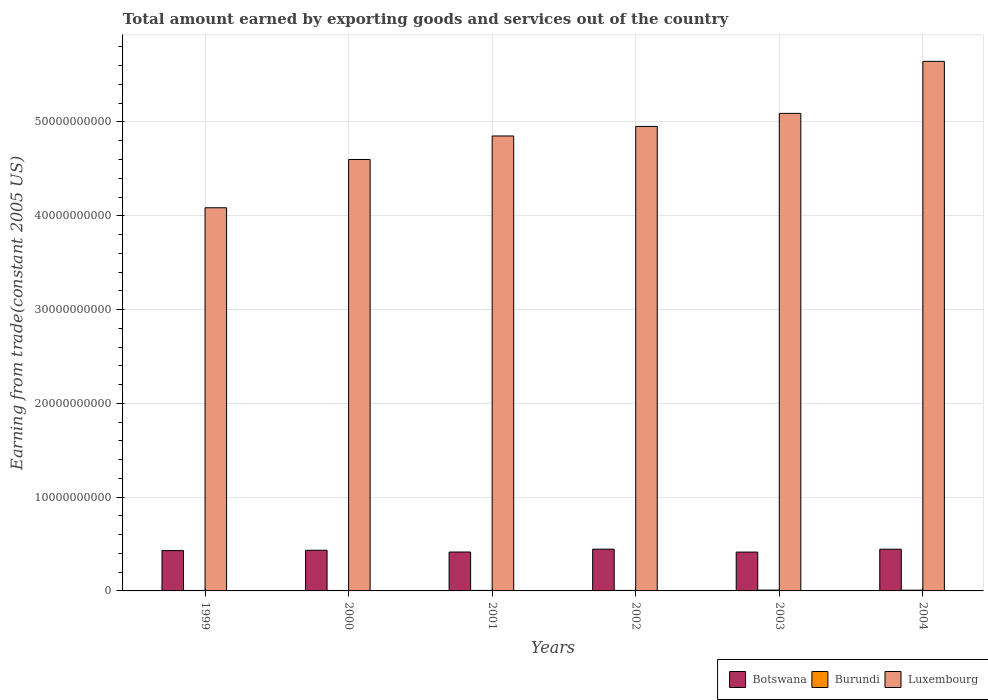Are the number of bars per tick equal to the number of legend labels?
Provide a short and direct response. Yes. Are the number of bars on each tick of the X-axis equal?
Your answer should be compact. Yes. How many bars are there on the 1st tick from the left?
Offer a very short reply. 3. What is the label of the 2nd group of bars from the left?
Provide a short and direct response. 2000. In how many cases, is the number of bars for a given year not equal to the number of legend labels?
Offer a terse response. 0. What is the total amount earned by exporting goods and services in Luxembourg in 2001?
Provide a succinct answer. 4.85e+1. Across all years, what is the maximum total amount earned by exporting goods and services in Burundi?
Offer a very short reply. 8.68e+07. Across all years, what is the minimum total amount earned by exporting goods and services in Botswana?
Your answer should be very brief. 4.14e+09. What is the total total amount earned by exporting goods and services in Burundi in the graph?
Your response must be concise. 3.69e+08. What is the difference between the total amount earned by exporting goods and services in Burundi in 2002 and that in 2004?
Make the answer very short. -2.42e+07. What is the difference between the total amount earned by exporting goods and services in Botswana in 2003 and the total amount earned by exporting goods and services in Luxembourg in 1999?
Provide a short and direct response. -3.67e+1. What is the average total amount earned by exporting goods and services in Burundi per year?
Make the answer very short. 6.16e+07. In the year 1999, what is the difference between the total amount earned by exporting goods and services in Botswana and total amount earned by exporting goods and services in Burundi?
Offer a terse response. 4.25e+09. What is the ratio of the total amount earned by exporting goods and services in Botswana in 2000 to that in 2001?
Your response must be concise. 1.05. Is the total amount earned by exporting goods and services in Burundi in 1999 less than that in 2003?
Provide a short and direct response. Yes. What is the difference between the highest and the second highest total amount earned by exporting goods and services in Luxembourg?
Provide a succinct answer. 5.55e+09. What is the difference between the highest and the lowest total amount earned by exporting goods and services in Botswana?
Your answer should be compact. 3.12e+08. Is the sum of the total amount earned by exporting goods and services in Luxembourg in 2000 and 2001 greater than the maximum total amount earned by exporting goods and services in Burundi across all years?
Offer a very short reply. Yes. What does the 3rd bar from the left in 2004 represents?
Keep it short and to the point. Luxembourg. What does the 2nd bar from the right in 2003 represents?
Make the answer very short. Burundi. Are all the bars in the graph horizontal?
Keep it short and to the point. No. How many years are there in the graph?
Offer a very short reply. 6. What is the difference between two consecutive major ticks on the Y-axis?
Offer a terse response. 1.00e+1. Does the graph contain any zero values?
Make the answer very short. No. Does the graph contain grids?
Your answer should be compact. Yes. How are the legend labels stacked?
Provide a succinct answer. Horizontal. What is the title of the graph?
Offer a very short reply. Total amount earned by exporting goods and services out of the country. Does "Luxembourg" appear as one of the legend labels in the graph?
Offer a terse response. Yes. What is the label or title of the Y-axis?
Your answer should be compact. Earning from trade(constant 2005 US). What is the Earning from trade(constant 2005 US) of Botswana in 1999?
Provide a succinct answer. 4.30e+09. What is the Earning from trade(constant 2005 US) of Burundi in 1999?
Make the answer very short. 4.87e+07. What is the Earning from trade(constant 2005 US) of Luxembourg in 1999?
Your answer should be very brief. 4.09e+1. What is the Earning from trade(constant 2005 US) in Botswana in 2000?
Give a very brief answer. 4.34e+09. What is the Earning from trade(constant 2005 US) of Burundi in 2000?
Provide a short and direct response. 4.50e+07. What is the Earning from trade(constant 2005 US) in Luxembourg in 2000?
Provide a succinct answer. 4.60e+1. What is the Earning from trade(constant 2005 US) in Botswana in 2001?
Offer a terse response. 4.15e+09. What is the Earning from trade(constant 2005 US) of Burundi in 2001?
Your answer should be compact. 5.65e+07. What is the Earning from trade(constant 2005 US) in Luxembourg in 2001?
Provide a succinct answer. 4.85e+1. What is the Earning from trade(constant 2005 US) in Botswana in 2002?
Give a very brief answer. 4.45e+09. What is the Earning from trade(constant 2005 US) of Burundi in 2002?
Your answer should be compact. 5.41e+07. What is the Earning from trade(constant 2005 US) in Luxembourg in 2002?
Give a very brief answer. 4.95e+1. What is the Earning from trade(constant 2005 US) of Botswana in 2003?
Keep it short and to the point. 4.14e+09. What is the Earning from trade(constant 2005 US) in Burundi in 2003?
Make the answer very short. 8.68e+07. What is the Earning from trade(constant 2005 US) of Luxembourg in 2003?
Provide a succinct answer. 5.09e+1. What is the Earning from trade(constant 2005 US) in Botswana in 2004?
Keep it short and to the point. 4.45e+09. What is the Earning from trade(constant 2005 US) in Burundi in 2004?
Provide a succinct answer. 7.84e+07. What is the Earning from trade(constant 2005 US) in Luxembourg in 2004?
Your answer should be very brief. 5.65e+1. Across all years, what is the maximum Earning from trade(constant 2005 US) of Botswana?
Your answer should be very brief. 4.45e+09. Across all years, what is the maximum Earning from trade(constant 2005 US) of Burundi?
Ensure brevity in your answer.  8.68e+07. Across all years, what is the maximum Earning from trade(constant 2005 US) of Luxembourg?
Ensure brevity in your answer.  5.65e+1. Across all years, what is the minimum Earning from trade(constant 2005 US) of Botswana?
Provide a succinct answer. 4.14e+09. Across all years, what is the minimum Earning from trade(constant 2005 US) of Burundi?
Provide a short and direct response. 4.50e+07. Across all years, what is the minimum Earning from trade(constant 2005 US) of Luxembourg?
Ensure brevity in your answer.  4.09e+1. What is the total Earning from trade(constant 2005 US) in Botswana in the graph?
Ensure brevity in your answer.  2.58e+1. What is the total Earning from trade(constant 2005 US) in Burundi in the graph?
Offer a terse response. 3.69e+08. What is the total Earning from trade(constant 2005 US) in Luxembourg in the graph?
Your answer should be compact. 2.92e+11. What is the difference between the Earning from trade(constant 2005 US) of Botswana in 1999 and that in 2000?
Give a very brief answer. -3.46e+07. What is the difference between the Earning from trade(constant 2005 US) in Burundi in 1999 and that in 2000?
Offer a terse response. 3.70e+06. What is the difference between the Earning from trade(constant 2005 US) in Luxembourg in 1999 and that in 2000?
Ensure brevity in your answer.  -5.15e+09. What is the difference between the Earning from trade(constant 2005 US) in Botswana in 1999 and that in 2001?
Keep it short and to the point. 1.54e+08. What is the difference between the Earning from trade(constant 2005 US) in Burundi in 1999 and that in 2001?
Make the answer very short. -7.73e+06. What is the difference between the Earning from trade(constant 2005 US) in Luxembourg in 1999 and that in 2001?
Keep it short and to the point. -7.65e+09. What is the difference between the Earning from trade(constant 2005 US) of Botswana in 1999 and that in 2002?
Ensure brevity in your answer.  -1.51e+08. What is the difference between the Earning from trade(constant 2005 US) of Burundi in 1999 and that in 2002?
Offer a very short reply. -5.39e+06. What is the difference between the Earning from trade(constant 2005 US) in Luxembourg in 1999 and that in 2002?
Provide a succinct answer. -8.67e+09. What is the difference between the Earning from trade(constant 2005 US) of Botswana in 1999 and that in 2003?
Your answer should be very brief. 1.61e+08. What is the difference between the Earning from trade(constant 2005 US) of Burundi in 1999 and that in 2003?
Your answer should be compact. -3.80e+07. What is the difference between the Earning from trade(constant 2005 US) in Luxembourg in 1999 and that in 2003?
Ensure brevity in your answer.  -1.01e+1. What is the difference between the Earning from trade(constant 2005 US) in Botswana in 1999 and that in 2004?
Provide a short and direct response. -1.45e+08. What is the difference between the Earning from trade(constant 2005 US) in Burundi in 1999 and that in 2004?
Your answer should be very brief. -2.96e+07. What is the difference between the Earning from trade(constant 2005 US) of Luxembourg in 1999 and that in 2004?
Offer a terse response. -1.56e+1. What is the difference between the Earning from trade(constant 2005 US) of Botswana in 2000 and that in 2001?
Offer a very short reply. 1.88e+08. What is the difference between the Earning from trade(constant 2005 US) of Burundi in 2000 and that in 2001?
Provide a succinct answer. -1.14e+07. What is the difference between the Earning from trade(constant 2005 US) of Luxembourg in 2000 and that in 2001?
Provide a short and direct response. -2.51e+09. What is the difference between the Earning from trade(constant 2005 US) of Botswana in 2000 and that in 2002?
Your answer should be compact. -1.16e+08. What is the difference between the Earning from trade(constant 2005 US) in Burundi in 2000 and that in 2002?
Give a very brief answer. -9.10e+06. What is the difference between the Earning from trade(constant 2005 US) in Luxembourg in 2000 and that in 2002?
Make the answer very short. -3.52e+09. What is the difference between the Earning from trade(constant 2005 US) in Botswana in 2000 and that in 2003?
Make the answer very short. 1.95e+08. What is the difference between the Earning from trade(constant 2005 US) in Burundi in 2000 and that in 2003?
Offer a terse response. -4.18e+07. What is the difference between the Earning from trade(constant 2005 US) in Luxembourg in 2000 and that in 2003?
Make the answer very short. -4.92e+09. What is the difference between the Earning from trade(constant 2005 US) in Botswana in 2000 and that in 2004?
Your answer should be very brief. -1.11e+08. What is the difference between the Earning from trade(constant 2005 US) in Burundi in 2000 and that in 2004?
Offer a terse response. -3.33e+07. What is the difference between the Earning from trade(constant 2005 US) in Luxembourg in 2000 and that in 2004?
Provide a short and direct response. -1.05e+1. What is the difference between the Earning from trade(constant 2005 US) in Botswana in 2001 and that in 2002?
Make the answer very short. -3.05e+08. What is the difference between the Earning from trade(constant 2005 US) in Burundi in 2001 and that in 2002?
Provide a short and direct response. 2.34e+06. What is the difference between the Earning from trade(constant 2005 US) in Luxembourg in 2001 and that in 2002?
Provide a short and direct response. -1.02e+09. What is the difference between the Earning from trade(constant 2005 US) of Botswana in 2001 and that in 2003?
Ensure brevity in your answer.  6.96e+06. What is the difference between the Earning from trade(constant 2005 US) of Burundi in 2001 and that in 2003?
Offer a very short reply. -3.03e+07. What is the difference between the Earning from trade(constant 2005 US) in Luxembourg in 2001 and that in 2003?
Make the answer very short. -2.41e+09. What is the difference between the Earning from trade(constant 2005 US) of Botswana in 2001 and that in 2004?
Keep it short and to the point. -2.99e+08. What is the difference between the Earning from trade(constant 2005 US) of Burundi in 2001 and that in 2004?
Your answer should be very brief. -2.19e+07. What is the difference between the Earning from trade(constant 2005 US) in Luxembourg in 2001 and that in 2004?
Keep it short and to the point. -7.96e+09. What is the difference between the Earning from trade(constant 2005 US) in Botswana in 2002 and that in 2003?
Your response must be concise. 3.12e+08. What is the difference between the Earning from trade(constant 2005 US) of Burundi in 2002 and that in 2003?
Your answer should be very brief. -3.27e+07. What is the difference between the Earning from trade(constant 2005 US) of Luxembourg in 2002 and that in 2003?
Your answer should be compact. -1.39e+09. What is the difference between the Earning from trade(constant 2005 US) of Botswana in 2002 and that in 2004?
Make the answer very short. 5.68e+06. What is the difference between the Earning from trade(constant 2005 US) of Burundi in 2002 and that in 2004?
Offer a terse response. -2.42e+07. What is the difference between the Earning from trade(constant 2005 US) in Luxembourg in 2002 and that in 2004?
Make the answer very short. -6.94e+09. What is the difference between the Earning from trade(constant 2005 US) in Botswana in 2003 and that in 2004?
Ensure brevity in your answer.  -3.06e+08. What is the difference between the Earning from trade(constant 2005 US) of Burundi in 2003 and that in 2004?
Offer a very short reply. 8.41e+06. What is the difference between the Earning from trade(constant 2005 US) of Luxembourg in 2003 and that in 2004?
Keep it short and to the point. -5.55e+09. What is the difference between the Earning from trade(constant 2005 US) of Botswana in 1999 and the Earning from trade(constant 2005 US) of Burundi in 2000?
Ensure brevity in your answer.  4.26e+09. What is the difference between the Earning from trade(constant 2005 US) in Botswana in 1999 and the Earning from trade(constant 2005 US) in Luxembourg in 2000?
Offer a terse response. -4.17e+1. What is the difference between the Earning from trade(constant 2005 US) in Burundi in 1999 and the Earning from trade(constant 2005 US) in Luxembourg in 2000?
Offer a very short reply. -4.60e+1. What is the difference between the Earning from trade(constant 2005 US) of Botswana in 1999 and the Earning from trade(constant 2005 US) of Burundi in 2001?
Offer a terse response. 4.25e+09. What is the difference between the Earning from trade(constant 2005 US) in Botswana in 1999 and the Earning from trade(constant 2005 US) in Luxembourg in 2001?
Your answer should be compact. -4.42e+1. What is the difference between the Earning from trade(constant 2005 US) in Burundi in 1999 and the Earning from trade(constant 2005 US) in Luxembourg in 2001?
Ensure brevity in your answer.  -4.85e+1. What is the difference between the Earning from trade(constant 2005 US) of Botswana in 1999 and the Earning from trade(constant 2005 US) of Burundi in 2002?
Your response must be concise. 4.25e+09. What is the difference between the Earning from trade(constant 2005 US) of Botswana in 1999 and the Earning from trade(constant 2005 US) of Luxembourg in 2002?
Your answer should be very brief. -4.52e+1. What is the difference between the Earning from trade(constant 2005 US) in Burundi in 1999 and the Earning from trade(constant 2005 US) in Luxembourg in 2002?
Your answer should be very brief. -4.95e+1. What is the difference between the Earning from trade(constant 2005 US) of Botswana in 1999 and the Earning from trade(constant 2005 US) of Burundi in 2003?
Give a very brief answer. 4.22e+09. What is the difference between the Earning from trade(constant 2005 US) of Botswana in 1999 and the Earning from trade(constant 2005 US) of Luxembourg in 2003?
Your response must be concise. -4.66e+1. What is the difference between the Earning from trade(constant 2005 US) in Burundi in 1999 and the Earning from trade(constant 2005 US) in Luxembourg in 2003?
Your response must be concise. -5.09e+1. What is the difference between the Earning from trade(constant 2005 US) of Botswana in 1999 and the Earning from trade(constant 2005 US) of Burundi in 2004?
Your answer should be very brief. 4.22e+09. What is the difference between the Earning from trade(constant 2005 US) of Botswana in 1999 and the Earning from trade(constant 2005 US) of Luxembourg in 2004?
Your answer should be very brief. -5.22e+1. What is the difference between the Earning from trade(constant 2005 US) in Burundi in 1999 and the Earning from trade(constant 2005 US) in Luxembourg in 2004?
Offer a very short reply. -5.64e+1. What is the difference between the Earning from trade(constant 2005 US) in Botswana in 2000 and the Earning from trade(constant 2005 US) in Burundi in 2001?
Offer a very short reply. 4.28e+09. What is the difference between the Earning from trade(constant 2005 US) in Botswana in 2000 and the Earning from trade(constant 2005 US) in Luxembourg in 2001?
Your answer should be very brief. -4.42e+1. What is the difference between the Earning from trade(constant 2005 US) in Burundi in 2000 and the Earning from trade(constant 2005 US) in Luxembourg in 2001?
Your answer should be compact. -4.85e+1. What is the difference between the Earning from trade(constant 2005 US) of Botswana in 2000 and the Earning from trade(constant 2005 US) of Burundi in 2002?
Keep it short and to the point. 4.28e+09. What is the difference between the Earning from trade(constant 2005 US) in Botswana in 2000 and the Earning from trade(constant 2005 US) in Luxembourg in 2002?
Ensure brevity in your answer.  -4.52e+1. What is the difference between the Earning from trade(constant 2005 US) of Burundi in 2000 and the Earning from trade(constant 2005 US) of Luxembourg in 2002?
Make the answer very short. -4.95e+1. What is the difference between the Earning from trade(constant 2005 US) in Botswana in 2000 and the Earning from trade(constant 2005 US) in Burundi in 2003?
Give a very brief answer. 4.25e+09. What is the difference between the Earning from trade(constant 2005 US) in Botswana in 2000 and the Earning from trade(constant 2005 US) in Luxembourg in 2003?
Offer a terse response. -4.66e+1. What is the difference between the Earning from trade(constant 2005 US) of Burundi in 2000 and the Earning from trade(constant 2005 US) of Luxembourg in 2003?
Your answer should be compact. -5.09e+1. What is the difference between the Earning from trade(constant 2005 US) of Botswana in 2000 and the Earning from trade(constant 2005 US) of Burundi in 2004?
Your answer should be very brief. 4.26e+09. What is the difference between the Earning from trade(constant 2005 US) in Botswana in 2000 and the Earning from trade(constant 2005 US) in Luxembourg in 2004?
Provide a succinct answer. -5.21e+1. What is the difference between the Earning from trade(constant 2005 US) in Burundi in 2000 and the Earning from trade(constant 2005 US) in Luxembourg in 2004?
Offer a terse response. -5.64e+1. What is the difference between the Earning from trade(constant 2005 US) in Botswana in 2001 and the Earning from trade(constant 2005 US) in Burundi in 2002?
Your answer should be compact. 4.09e+09. What is the difference between the Earning from trade(constant 2005 US) in Botswana in 2001 and the Earning from trade(constant 2005 US) in Luxembourg in 2002?
Keep it short and to the point. -4.54e+1. What is the difference between the Earning from trade(constant 2005 US) of Burundi in 2001 and the Earning from trade(constant 2005 US) of Luxembourg in 2002?
Offer a terse response. -4.95e+1. What is the difference between the Earning from trade(constant 2005 US) in Botswana in 2001 and the Earning from trade(constant 2005 US) in Burundi in 2003?
Provide a short and direct response. 4.06e+09. What is the difference between the Earning from trade(constant 2005 US) of Botswana in 2001 and the Earning from trade(constant 2005 US) of Luxembourg in 2003?
Your response must be concise. -4.68e+1. What is the difference between the Earning from trade(constant 2005 US) in Burundi in 2001 and the Earning from trade(constant 2005 US) in Luxembourg in 2003?
Ensure brevity in your answer.  -5.09e+1. What is the difference between the Earning from trade(constant 2005 US) in Botswana in 2001 and the Earning from trade(constant 2005 US) in Burundi in 2004?
Make the answer very short. 4.07e+09. What is the difference between the Earning from trade(constant 2005 US) of Botswana in 2001 and the Earning from trade(constant 2005 US) of Luxembourg in 2004?
Ensure brevity in your answer.  -5.23e+1. What is the difference between the Earning from trade(constant 2005 US) in Burundi in 2001 and the Earning from trade(constant 2005 US) in Luxembourg in 2004?
Ensure brevity in your answer.  -5.64e+1. What is the difference between the Earning from trade(constant 2005 US) of Botswana in 2002 and the Earning from trade(constant 2005 US) of Burundi in 2003?
Make the answer very short. 4.37e+09. What is the difference between the Earning from trade(constant 2005 US) of Botswana in 2002 and the Earning from trade(constant 2005 US) of Luxembourg in 2003?
Ensure brevity in your answer.  -4.65e+1. What is the difference between the Earning from trade(constant 2005 US) of Burundi in 2002 and the Earning from trade(constant 2005 US) of Luxembourg in 2003?
Offer a very short reply. -5.09e+1. What is the difference between the Earning from trade(constant 2005 US) in Botswana in 2002 and the Earning from trade(constant 2005 US) in Burundi in 2004?
Keep it short and to the point. 4.37e+09. What is the difference between the Earning from trade(constant 2005 US) of Botswana in 2002 and the Earning from trade(constant 2005 US) of Luxembourg in 2004?
Your answer should be very brief. -5.20e+1. What is the difference between the Earning from trade(constant 2005 US) of Burundi in 2002 and the Earning from trade(constant 2005 US) of Luxembourg in 2004?
Your response must be concise. -5.64e+1. What is the difference between the Earning from trade(constant 2005 US) of Botswana in 2003 and the Earning from trade(constant 2005 US) of Burundi in 2004?
Your answer should be very brief. 4.06e+09. What is the difference between the Earning from trade(constant 2005 US) in Botswana in 2003 and the Earning from trade(constant 2005 US) in Luxembourg in 2004?
Give a very brief answer. -5.23e+1. What is the difference between the Earning from trade(constant 2005 US) of Burundi in 2003 and the Earning from trade(constant 2005 US) of Luxembourg in 2004?
Offer a terse response. -5.64e+1. What is the average Earning from trade(constant 2005 US) in Botswana per year?
Offer a terse response. 4.30e+09. What is the average Earning from trade(constant 2005 US) of Burundi per year?
Offer a terse response. 6.16e+07. What is the average Earning from trade(constant 2005 US) in Luxembourg per year?
Provide a succinct answer. 4.87e+1. In the year 1999, what is the difference between the Earning from trade(constant 2005 US) in Botswana and Earning from trade(constant 2005 US) in Burundi?
Make the answer very short. 4.25e+09. In the year 1999, what is the difference between the Earning from trade(constant 2005 US) in Botswana and Earning from trade(constant 2005 US) in Luxembourg?
Give a very brief answer. -3.66e+1. In the year 1999, what is the difference between the Earning from trade(constant 2005 US) of Burundi and Earning from trade(constant 2005 US) of Luxembourg?
Make the answer very short. -4.08e+1. In the year 2000, what is the difference between the Earning from trade(constant 2005 US) of Botswana and Earning from trade(constant 2005 US) of Burundi?
Your answer should be compact. 4.29e+09. In the year 2000, what is the difference between the Earning from trade(constant 2005 US) of Botswana and Earning from trade(constant 2005 US) of Luxembourg?
Make the answer very short. -4.17e+1. In the year 2000, what is the difference between the Earning from trade(constant 2005 US) in Burundi and Earning from trade(constant 2005 US) in Luxembourg?
Provide a short and direct response. -4.60e+1. In the year 2001, what is the difference between the Earning from trade(constant 2005 US) of Botswana and Earning from trade(constant 2005 US) of Burundi?
Your response must be concise. 4.09e+09. In the year 2001, what is the difference between the Earning from trade(constant 2005 US) in Botswana and Earning from trade(constant 2005 US) in Luxembourg?
Give a very brief answer. -4.44e+1. In the year 2001, what is the difference between the Earning from trade(constant 2005 US) in Burundi and Earning from trade(constant 2005 US) in Luxembourg?
Give a very brief answer. -4.85e+1. In the year 2002, what is the difference between the Earning from trade(constant 2005 US) in Botswana and Earning from trade(constant 2005 US) in Burundi?
Your response must be concise. 4.40e+09. In the year 2002, what is the difference between the Earning from trade(constant 2005 US) of Botswana and Earning from trade(constant 2005 US) of Luxembourg?
Ensure brevity in your answer.  -4.51e+1. In the year 2002, what is the difference between the Earning from trade(constant 2005 US) in Burundi and Earning from trade(constant 2005 US) in Luxembourg?
Offer a very short reply. -4.95e+1. In the year 2003, what is the difference between the Earning from trade(constant 2005 US) in Botswana and Earning from trade(constant 2005 US) in Burundi?
Ensure brevity in your answer.  4.05e+09. In the year 2003, what is the difference between the Earning from trade(constant 2005 US) in Botswana and Earning from trade(constant 2005 US) in Luxembourg?
Provide a short and direct response. -4.68e+1. In the year 2003, what is the difference between the Earning from trade(constant 2005 US) in Burundi and Earning from trade(constant 2005 US) in Luxembourg?
Your answer should be very brief. -5.08e+1. In the year 2004, what is the difference between the Earning from trade(constant 2005 US) of Botswana and Earning from trade(constant 2005 US) of Burundi?
Offer a terse response. 4.37e+09. In the year 2004, what is the difference between the Earning from trade(constant 2005 US) in Botswana and Earning from trade(constant 2005 US) in Luxembourg?
Your answer should be very brief. -5.20e+1. In the year 2004, what is the difference between the Earning from trade(constant 2005 US) of Burundi and Earning from trade(constant 2005 US) of Luxembourg?
Keep it short and to the point. -5.64e+1. What is the ratio of the Earning from trade(constant 2005 US) in Burundi in 1999 to that in 2000?
Offer a terse response. 1.08. What is the ratio of the Earning from trade(constant 2005 US) in Luxembourg in 1999 to that in 2000?
Provide a succinct answer. 0.89. What is the ratio of the Earning from trade(constant 2005 US) in Botswana in 1999 to that in 2001?
Ensure brevity in your answer.  1.04. What is the ratio of the Earning from trade(constant 2005 US) in Burundi in 1999 to that in 2001?
Provide a succinct answer. 0.86. What is the ratio of the Earning from trade(constant 2005 US) in Luxembourg in 1999 to that in 2001?
Your answer should be compact. 0.84. What is the ratio of the Earning from trade(constant 2005 US) of Botswana in 1999 to that in 2002?
Your response must be concise. 0.97. What is the ratio of the Earning from trade(constant 2005 US) in Burundi in 1999 to that in 2002?
Offer a very short reply. 0.9. What is the ratio of the Earning from trade(constant 2005 US) in Luxembourg in 1999 to that in 2002?
Provide a short and direct response. 0.82. What is the ratio of the Earning from trade(constant 2005 US) in Botswana in 1999 to that in 2003?
Ensure brevity in your answer.  1.04. What is the ratio of the Earning from trade(constant 2005 US) in Burundi in 1999 to that in 2003?
Provide a short and direct response. 0.56. What is the ratio of the Earning from trade(constant 2005 US) in Luxembourg in 1999 to that in 2003?
Provide a succinct answer. 0.8. What is the ratio of the Earning from trade(constant 2005 US) in Botswana in 1999 to that in 2004?
Your answer should be compact. 0.97. What is the ratio of the Earning from trade(constant 2005 US) in Burundi in 1999 to that in 2004?
Your answer should be compact. 0.62. What is the ratio of the Earning from trade(constant 2005 US) of Luxembourg in 1999 to that in 2004?
Your answer should be very brief. 0.72. What is the ratio of the Earning from trade(constant 2005 US) in Botswana in 2000 to that in 2001?
Give a very brief answer. 1.05. What is the ratio of the Earning from trade(constant 2005 US) in Burundi in 2000 to that in 2001?
Provide a succinct answer. 0.8. What is the ratio of the Earning from trade(constant 2005 US) in Luxembourg in 2000 to that in 2001?
Make the answer very short. 0.95. What is the ratio of the Earning from trade(constant 2005 US) of Botswana in 2000 to that in 2002?
Your answer should be very brief. 0.97. What is the ratio of the Earning from trade(constant 2005 US) of Burundi in 2000 to that in 2002?
Provide a succinct answer. 0.83. What is the ratio of the Earning from trade(constant 2005 US) in Luxembourg in 2000 to that in 2002?
Provide a succinct answer. 0.93. What is the ratio of the Earning from trade(constant 2005 US) of Botswana in 2000 to that in 2003?
Your answer should be compact. 1.05. What is the ratio of the Earning from trade(constant 2005 US) of Burundi in 2000 to that in 2003?
Provide a succinct answer. 0.52. What is the ratio of the Earning from trade(constant 2005 US) of Luxembourg in 2000 to that in 2003?
Your answer should be compact. 0.9. What is the ratio of the Earning from trade(constant 2005 US) in Botswana in 2000 to that in 2004?
Ensure brevity in your answer.  0.98. What is the ratio of the Earning from trade(constant 2005 US) in Burundi in 2000 to that in 2004?
Provide a succinct answer. 0.57. What is the ratio of the Earning from trade(constant 2005 US) in Luxembourg in 2000 to that in 2004?
Your answer should be very brief. 0.81. What is the ratio of the Earning from trade(constant 2005 US) of Botswana in 2001 to that in 2002?
Keep it short and to the point. 0.93. What is the ratio of the Earning from trade(constant 2005 US) of Burundi in 2001 to that in 2002?
Ensure brevity in your answer.  1.04. What is the ratio of the Earning from trade(constant 2005 US) in Luxembourg in 2001 to that in 2002?
Offer a very short reply. 0.98. What is the ratio of the Earning from trade(constant 2005 US) of Botswana in 2001 to that in 2003?
Give a very brief answer. 1. What is the ratio of the Earning from trade(constant 2005 US) of Burundi in 2001 to that in 2003?
Give a very brief answer. 0.65. What is the ratio of the Earning from trade(constant 2005 US) of Luxembourg in 2001 to that in 2003?
Provide a succinct answer. 0.95. What is the ratio of the Earning from trade(constant 2005 US) of Botswana in 2001 to that in 2004?
Ensure brevity in your answer.  0.93. What is the ratio of the Earning from trade(constant 2005 US) in Burundi in 2001 to that in 2004?
Provide a succinct answer. 0.72. What is the ratio of the Earning from trade(constant 2005 US) of Luxembourg in 2001 to that in 2004?
Provide a succinct answer. 0.86. What is the ratio of the Earning from trade(constant 2005 US) in Botswana in 2002 to that in 2003?
Ensure brevity in your answer.  1.08. What is the ratio of the Earning from trade(constant 2005 US) of Burundi in 2002 to that in 2003?
Provide a short and direct response. 0.62. What is the ratio of the Earning from trade(constant 2005 US) in Luxembourg in 2002 to that in 2003?
Offer a terse response. 0.97. What is the ratio of the Earning from trade(constant 2005 US) of Burundi in 2002 to that in 2004?
Give a very brief answer. 0.69. What is the ratio of the Earning from trade(constant 2005 US) in Luxembourg in 2002 to that in 2004?
Ensure brevity in your answer.  0.88. What is the ratio of the Earning from trade(constant 2005 US) of Botswana in 2003 to that in 2004?
Your answer should be compact. 0.93. What is the ratio of the Earning from trade(constant 2005 US) in Burundi in 2003 to that in 2004?
Provide a succinct answer. 1.11. What is the ratio of the Earning from trade(constant 2005 US) in Luxembourg in 2003 to that in 2004?
Provide a short and direct response. 0.9. What is the difference between the highest and the second highest Earning from trade(constant 2005 US) of Botswana?
Offer a very short reply. 5.68e+06. What is the difference between the highest and the second highest Earning from trade(constant 2005 US) of Burundi?
Make the answer very short. 8.41e+06. What is the difference between the highest and the second highest Earning from trade(constant 2005 US) in Luxembourg?
Ensure brevity in your answer.  5.55e+09. What is the difference between the highest and the lowest Earning from trade(constant 2005 US) in Botswana?
Provide a short and direct response. 3.12e+08. What is the difference between the highest and the lowest Earning from trade(constant 2005 US) in Burundi?
Provide a succinct answer. 4.18e+07. What is the difference between the highest and the lowest Earning from trade(constant 2005 US) in Luxembourg?
Offer a terse response. 1.56e+1. 